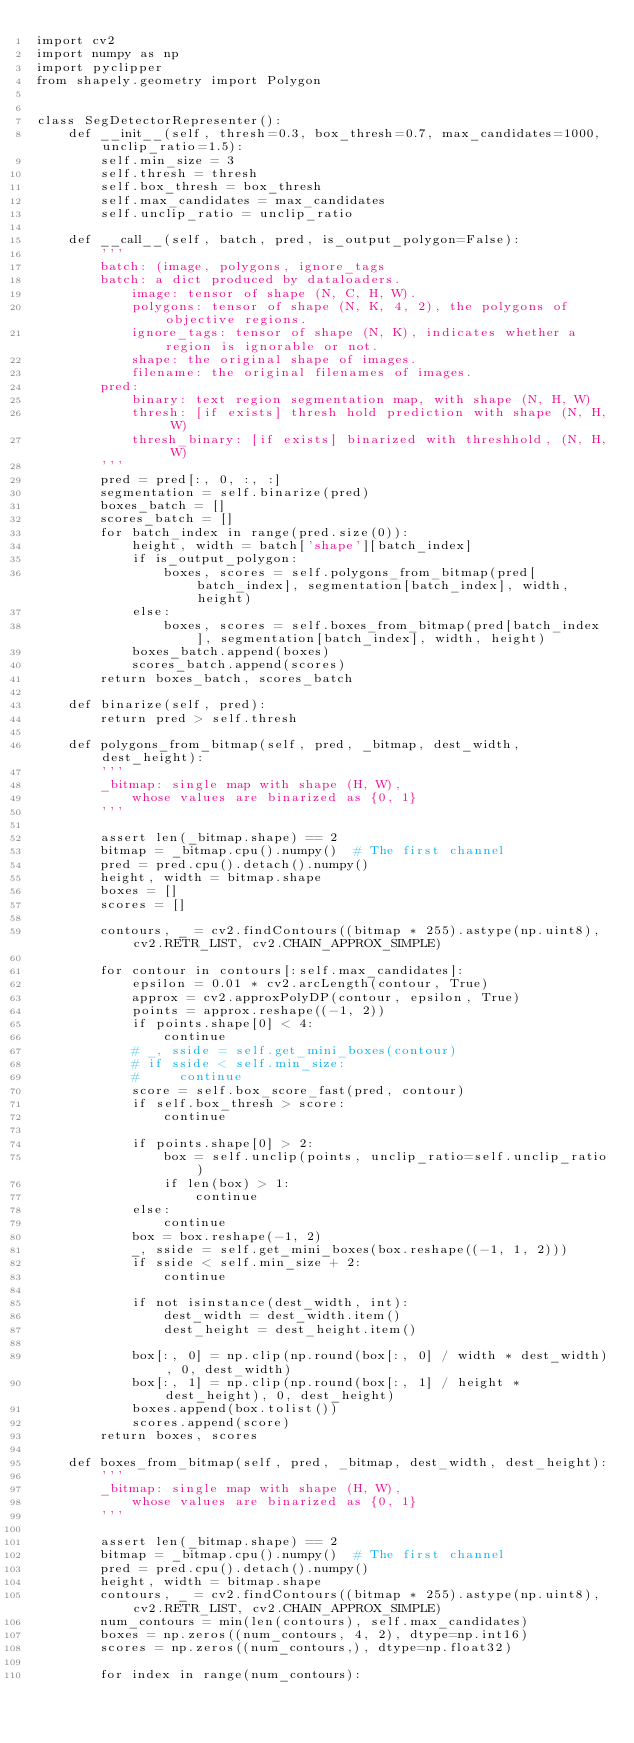<code> <loc_0><loc_0><loc_500><loc_500><_Python_>import cv2
import numpy as np
import pyclipper
from shapely.geometry import Polygon


class SegDetectorRepresenter():
    def __init__(self, thresh=0.3, box_thresh=0.7, max_candidates=1000, unclip_ratio=1.5):
        self.min_size = 3
        self.thresh = thresh
        self.box_thresh = box_thresh
        self.max_candidates = max_candidates
        self.unclip_ratio = unclip_ratio

    def __call__(self, batch, pred, is_output_polygon=False):
        '''
        batch: (image, polygons, ignore_tags
        batch: a dict produced by dataloaders.
            image: tensor of shape (N, C, H, W).
            polygons: tensor of shape (N, K, 4, 2), the polygons of objective regions.
            ignore_tags: tensor of shape (N, K), indicates whether a region is ignorable or not.
            shape: the original shape of images.
            filename: the original filenames of images.
        pred:
            binary: text region segmentation map, with shape (N, H, W)
            thresh: [if exists] thresh hold prediction with shape (N, H, W)
            thresh_binary: [if exists] binarized with threshhold, (N, H, W)
        '''
        pred = pred[:, 0, :, :]
        segmentation = self.binarize(pred)
        boxes_batch = []
        scores_batch = []
        for batch_index in range(pred.size(0)):
            height, width = batch['shape'][batch_index]
            if is_output_polygon:
                boxes, scores = self.polygons_from_bitmap(pred[batch_index], segmentation[batch_index], width, height)
            else:
                boxes, scores = self.boxes_from_bitmap(pred[batch_index], segmentation[batch_index], width, height)
            boxes_batch.append(boxes)
            scores_batch.append(scores)
        return boxes_batch, scores_batch

    def binarize(self, pred):
        return pred > self.thresh

    def polygons_from_bitmap(self, pred, _bitmap, dest_width, dest_height):
        '''
        _bitmap: single map with shape (H, W),
            whose values are binarized as {0, 1}
        '''

        assert len(_bitmap.shape) == 2
        bitmap = _bitmap.cpu().numpy()  # The first channel
        pred = pred.cpu().detach().numpy()
        height, width = bitmap.shape
        boxes = []
        scores = []

        contours, _ = cv2.findContours((bitmap * 255).astype(np.uint8), cv2.RETR_LIST, cv2.CHAIN_APPROX_SIMPLE)

        for contour in contours[:self.max_candidates]:
            epsilon = 0.01 * cv2.arcLength(contour, True)
            approx = cv2.approxPolyDP(contour, epsilon, True)
            points = approx.reshape((-1, 2))
            if points.shape[0] < 4:
                continue
            # _, sside = self.get_mini_boxes(contour)
            # if sside < self.min_size:
            #     continue
            score = self.box_score_fast(pred, contour)
            if self.box_thresh > score:
                continue

            if points.shape[0] > 2:
                box = self.unclip(points, unclip_ratio=self.unclip_ratio)
                if len(box) > 1:
                    continue
            else:
                continue
            box = box.reshape(-1, 2)
            _, sside = self.get_mini_boxes(box.reshape((-1, 1, 2)))
            if sside < self.min_size + 2:
                continue

            if not isinstance(dest_width, int):
                dest_width = dest_width.item()
                dest_height = dest_height.item()

            box[:, 0] = np.clip(np.round(box[:, 0] / width * dest_width), 0, dest_width)
            box[:, 1] = np.clip(np.round(box[:, 1] / height * dest_height), 0, dest_height)
            boxes.append(box.tolist())
            scores.append(score)
        return boxes, scores

    def boxes_from_bitmap(self, pred, _bitmap, dest_width, dest_height):
        '''
        _bitmap: single map with shape (H, W),
            whose values are binarized as {0, 1}
        '''

        assert len(_bitmap.shape) == 2
        bitmap = _bitmap.cpu().numpy()  # The first channel
        pred = pred.cpu().detach().numpy()
        height, width = bitmap.shape
        contours, _ = cv2.findContours((bitmap * 255).astype(np.uint8), cv2.RETR_LIST, cv2.CHAIN_APPROX_SIMPLE)
        num_contours = min(len(contours), self.max_candidates)
        boxes = np.zeros((num_contours, 4, 2), dtype=np.int16)
        scores = np.zeros((num_contours,), dtype=np.float32)

        for index in range(num_contours):</code> 